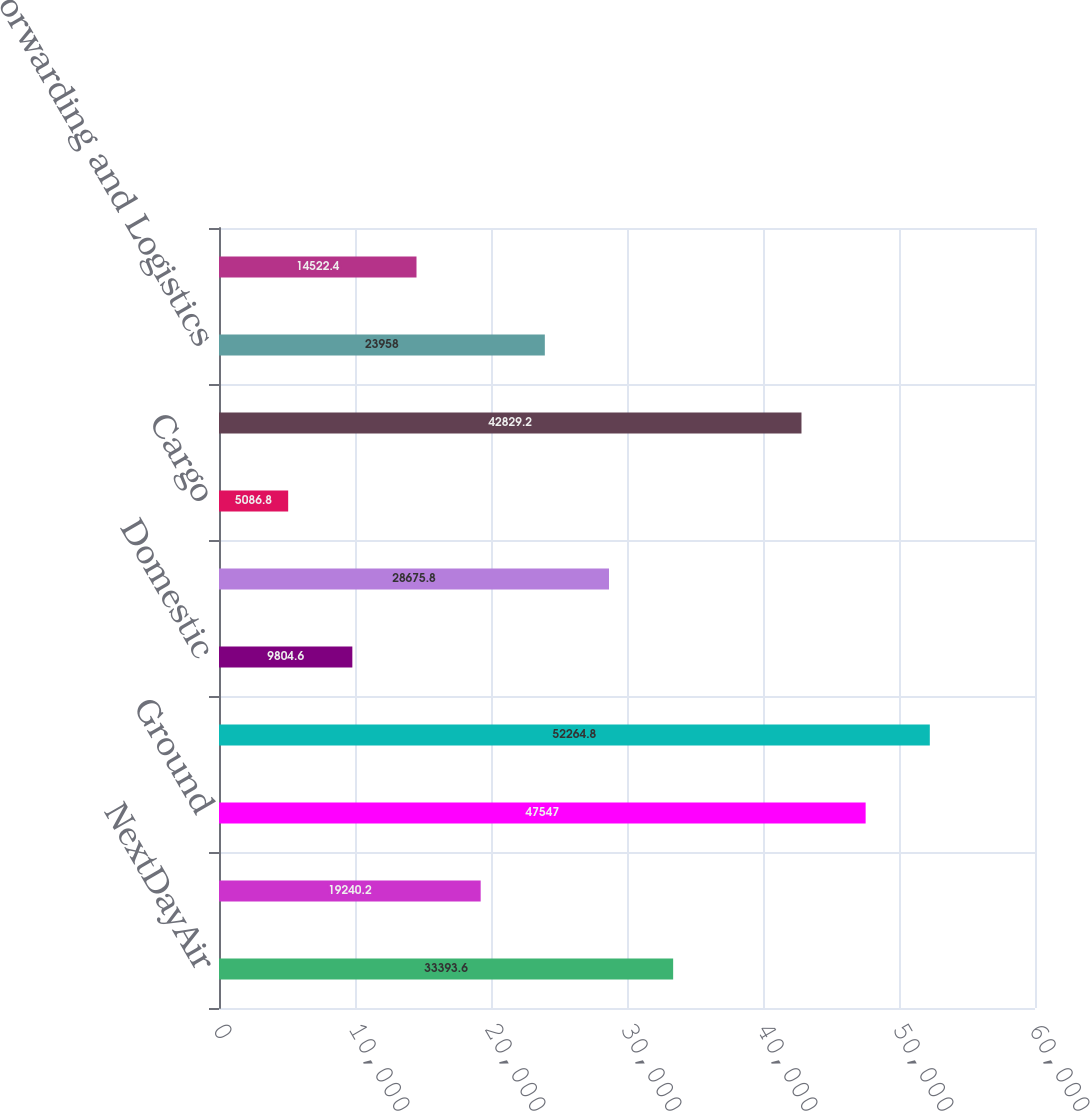Convert chart to OTSL. <chart><loc_0><loc_0><loc_500><loc_500><bar_chart><fcel>NextDayAir<fcel>Deferred<fcel>Ground<fcel>Total US Domestic Package<fcel>Domestic<fcel>Export<fcel>Cargo<fcel>Total International Package<fcel>Forwarding and Logistics<fcel>Freight<nl><fcel>33393.6<fcel>19240.2<fcel>47547<fcel>52264.8<fcel>9804.6<fcel>28675.8<fcel>5086.8<fcel>42829.2<fcel>23958<fcel>14522.4<nl></chart> 